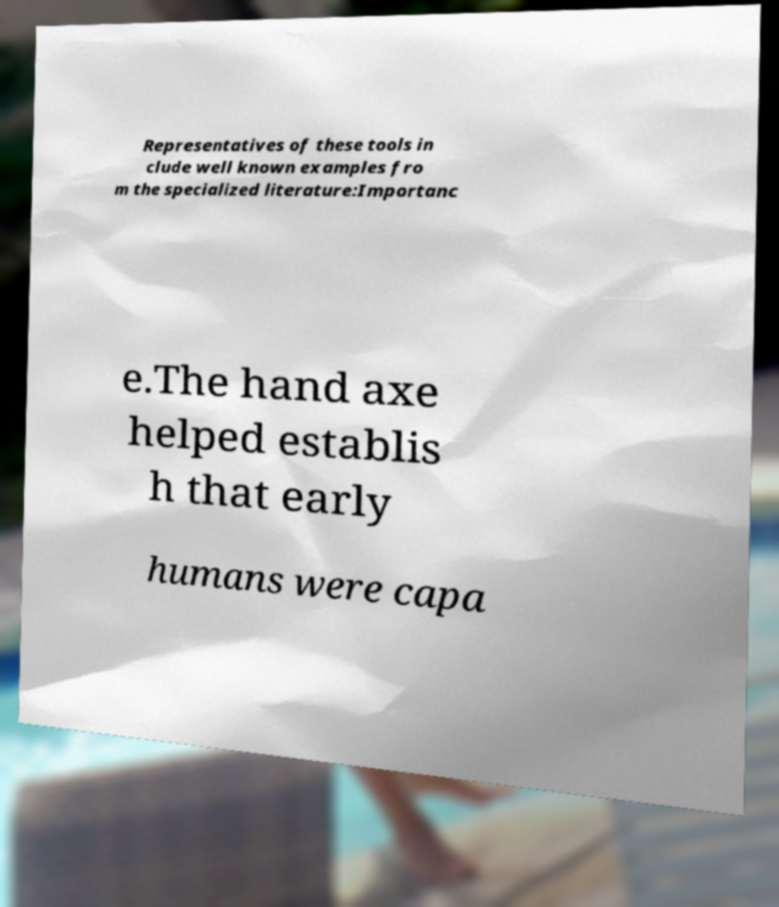For documentation purposes, I need the text within this image transcribed. Could you provide that? Representatives of these tools in clude well known examples fro m the specialized literature:Importanc e.The hand axe helped establis h that early humans were capa 